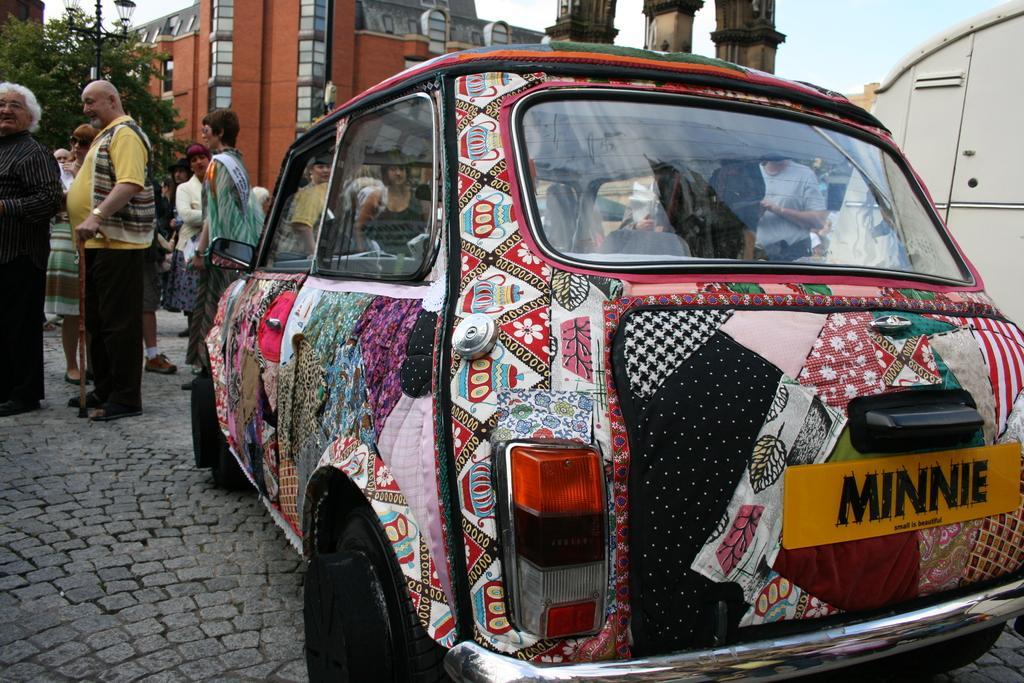Please provide a concise description of this image. In this image I can see the vehicles which are colorful. In the background I can see the group of people with different colored dressers. I can also see the pole, trees, buildings and the sky. 